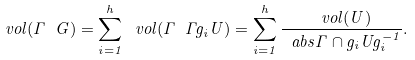Convert formula to latex. <formula><loc_0><loc_0><loc_500><loc_500>\ v o l ( \Gamma \ G ) = \sum _ { i = 1 } ^ { h } \ v o l ( \Gamma \ \Gamma g _ { i } U ) = \sum _ { i = 1 } ^ { h } \frac { \ v o l ( U ) } { \ a b s { \Gamma \cap g _ { i } U g _ { i } ^ { - 1 } } } .</formula> 